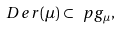<formula> <loc_0><loc_0><loc_500><loc_500>\ D e r ( \mu ) \subset \ p g _ { \mu } ,</formula> 